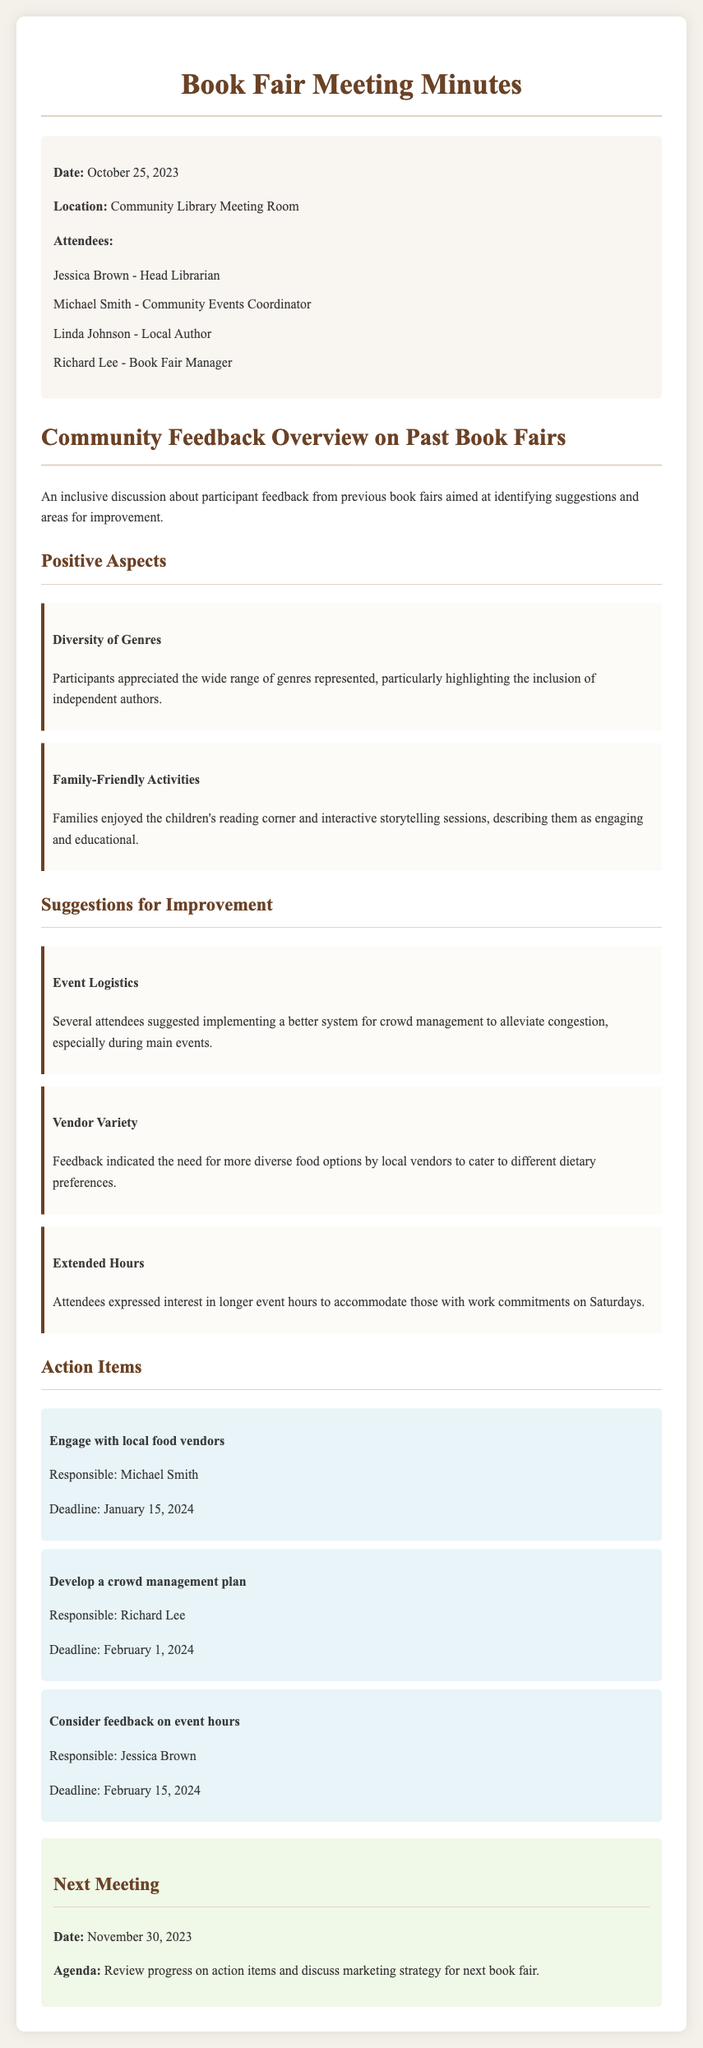what is the date of the meeting? The date of the meeting is specifically mentioned in the meta-info section of the document.
Answer: October 25, 2023 who is the Head Librarian? The document lists the attendees along with their titles, identifying who holds the position of Head Librarian.
Answer: Jessica Brown what are two positive aspects mentioned about the book fairs? The feedback section highlights several positive aspects, specifically mentioning two key praises.
Answer: Diversity of Genres, Family-Friendly Activities what is one suggestion for improvement regarding event logistics? The feedback section discusses suggestions for improvement, including specific points mentioned by attendees.
Answer: Better crowd management system who is responsible for engaging with local food vendors? The action items section outlines responsibilities for different individuals regarding feedback implementation.
Answer: Michael Smith when is the next meeting scheduled? The next meeting date is listed at the end of the document.
Answer: November 30, 2023 what is an area of focus for the next meeting? The agenda for the next meeting includes specific points for discussion.
Answer: Review progress on action items what is one area for improvement related to food at the book fairs? The suggestions for improvement section mentions specific feedback about food options provided at the fairs.
Answer: More diverse food options what is the deadline for developing a crowd management plan? The action items section specifies deadlines for each responsibility mentioned.
Answer: February 1, 2024 